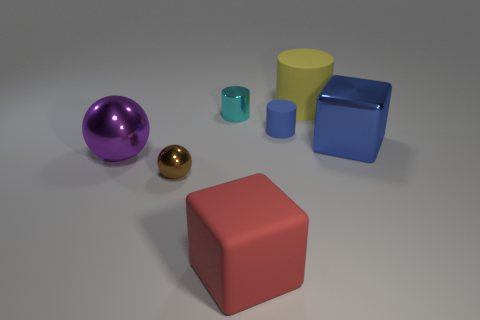What number of blue metal objects have the same shape as the brown thing?
Your response must be concise. 0. There is a metal sphere that is the same size as the blue cylinder; what is its color?
Your response must be concise. Brown. Are there an equal number of small metallic spheres in front of the brown object and purple shiny things to the right of the blue rubber thing?
Provide a succinct answer. Yes. Is there a green thing that has the same size as the blue block?
Your response must be concise. No. The red cube is what size?
Provide a succinct answer. Large. Is the number of tiny blue rubber things that are to the left of the tiny metal cylinder the same as the number of small blue matte blocks?
Your answer should be compact. Yes. How many other things are the same color as the tiny shiny ball?
Your response must be concise. 0. What color is the thing that is left of the large blue thing and on the right side of the blue cylinder?
Provide a short and direct response. Yellow. There is a matte object that is on the right side of the matte cylinder that is in front of the metallic object that is behind the large blue thing; what is its size?
Offer a very short reply. Large. How many things are either large things that are behind the purple object or cubes that are behind the large ball?
Make the answer very short. 2. 